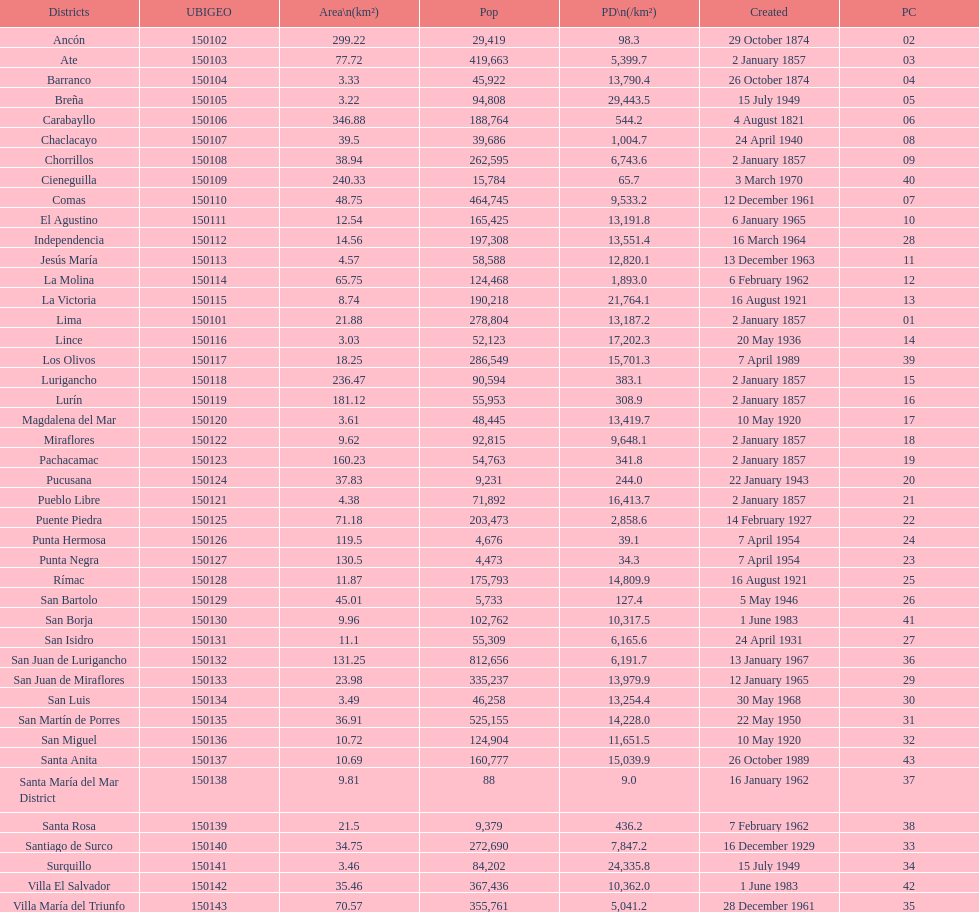0? 31. 